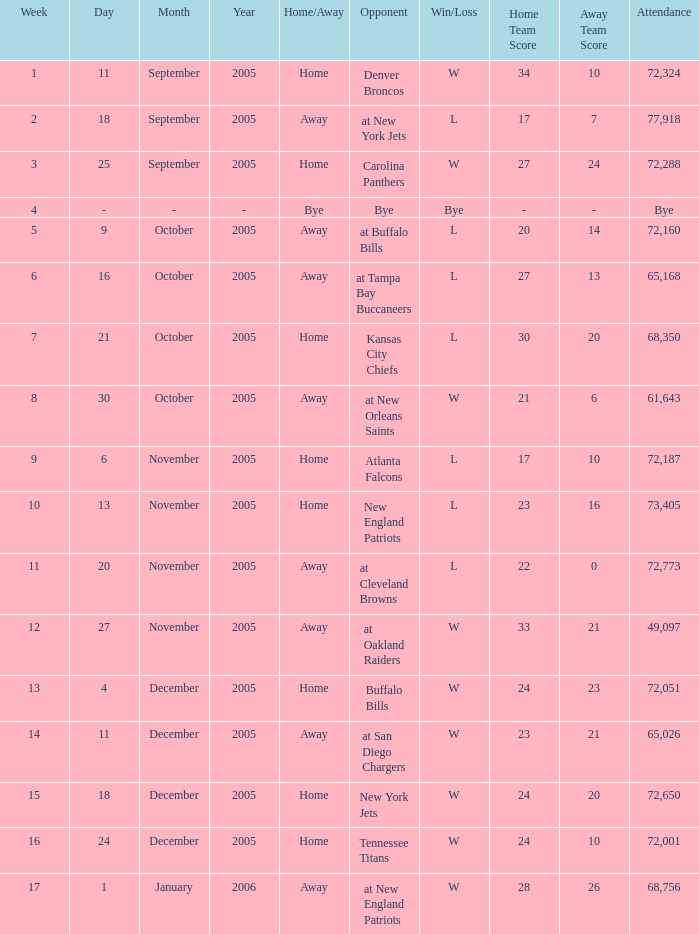Who was the Opponent on November 27, 2005? At oakland raiders. 